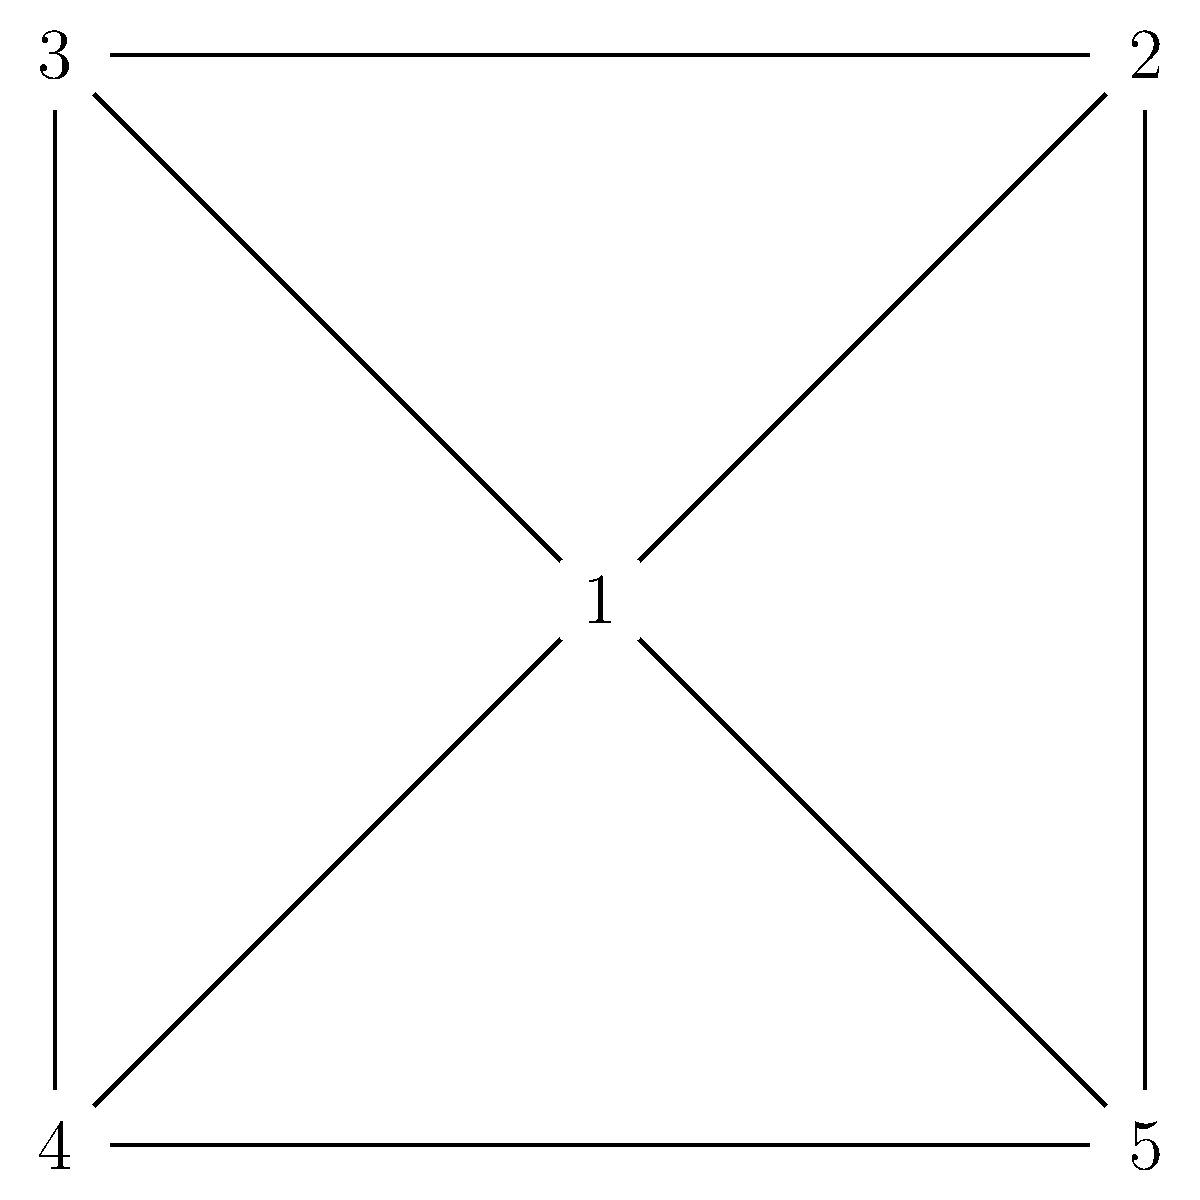In a classic pixelated game world, you need to assign character types to different areas represented by the vertices of the graph above. Adjacent areas must have different character types. What is the minimum number of character types (colors) needed to properly color this graph? To determine the minimum number of colors needed to properly color this graph, we can follow these steps:

1. Observe that the graph is a complete graph $K_5$, where every vertex is connected to every other vertex.

2. In a complete graph $K_n$, each vertex must have a different color because it is adjacent to all other vertices.

3. The chromatic number $\chi(G)$ of a complete graph $K_n$ is always equal to $n$.

4. In this case, we have $K_5$, so the chromatic number is 5.

5. This means we need at least 5 different colors (or character types) to ensure that no two adjacent vertices have the same color.

6. Practically, in the game world, this translates to needing 5 distinct character types to populate the areas represented by the vertices, ensuring that no two adjacent areas have the same character type.
Answer: 5 